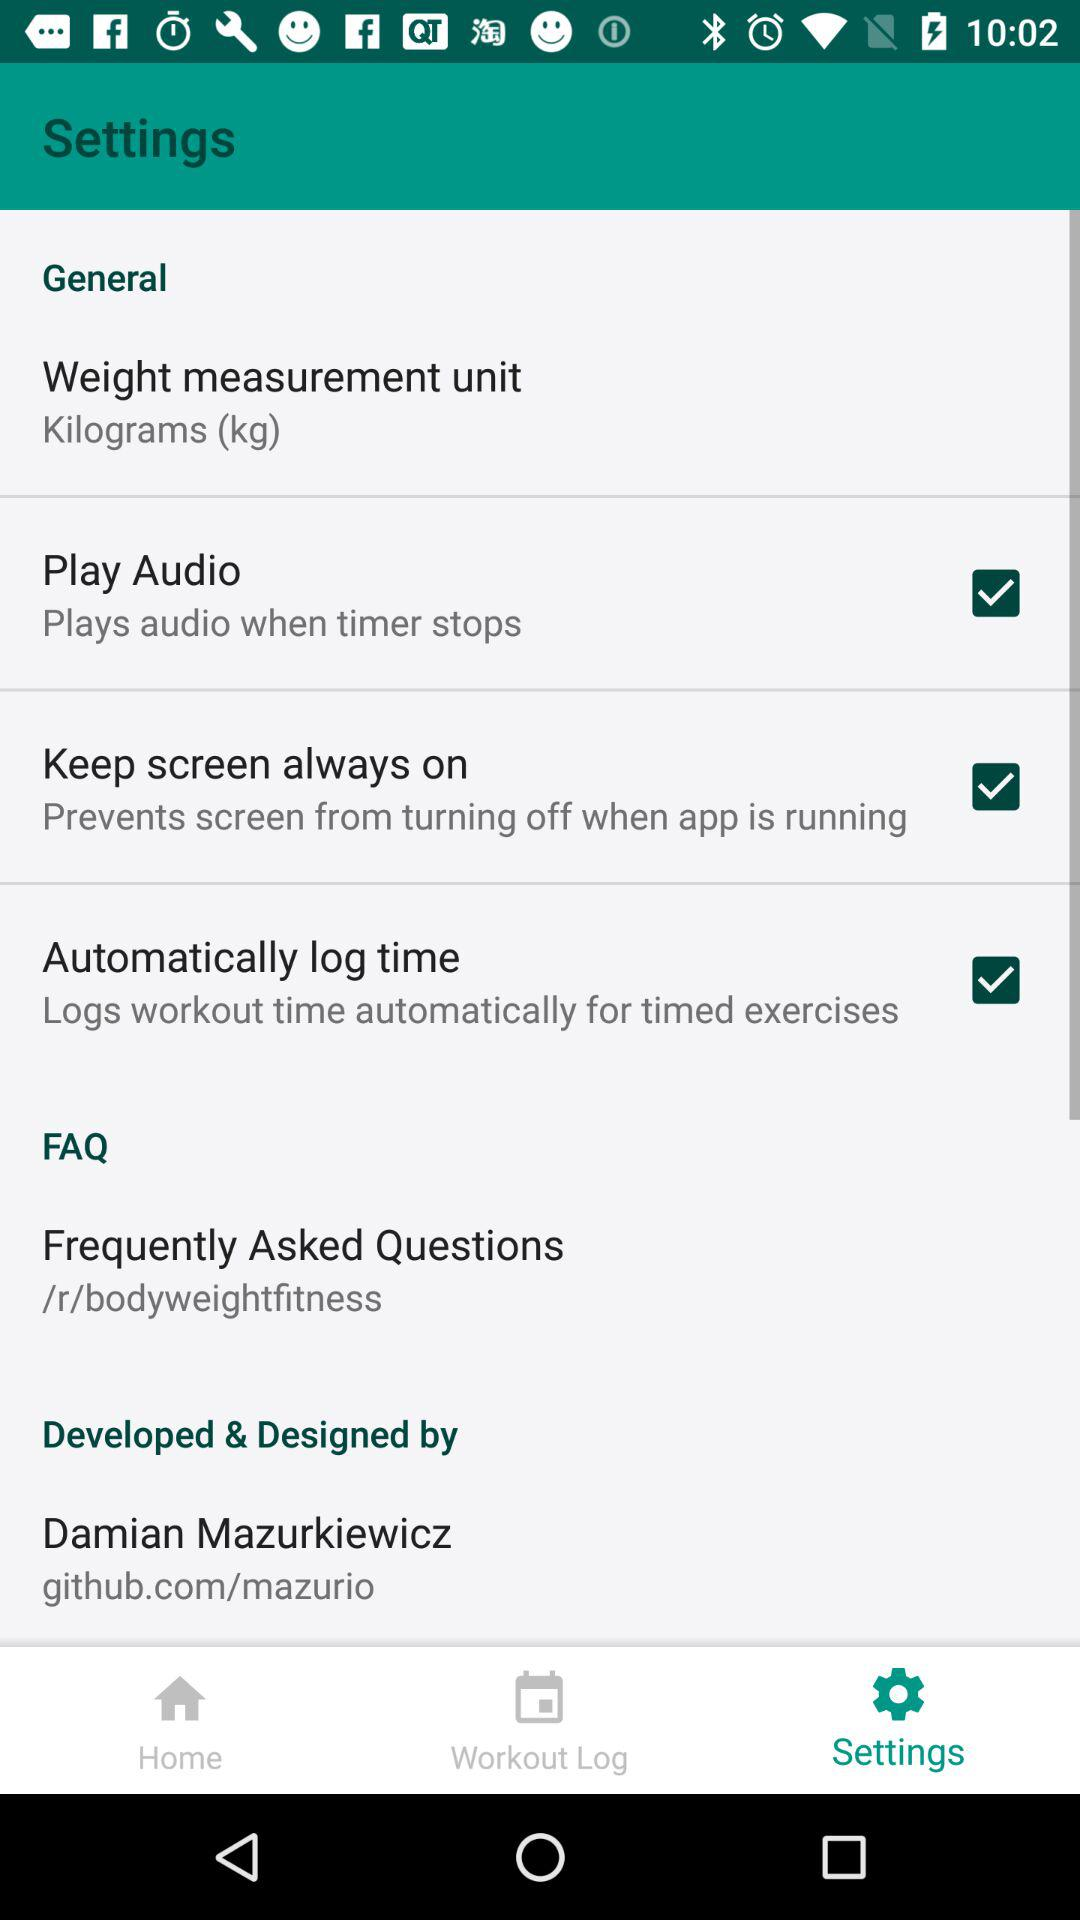How many items are on the Settings screen?
Answer the question using a single word or phrase. 6 